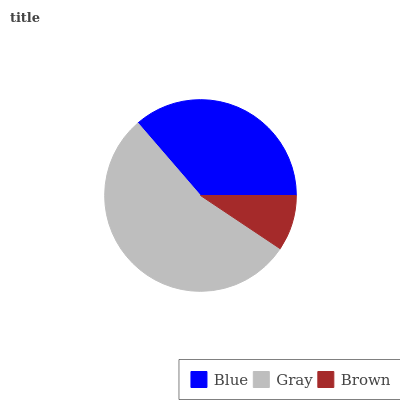Is Brown the minimum?
Answer yes or no. Yes. Is Gray the maximum?
Answer yes or no. Yes. Is Gray the minimum?
Answer yes or no. No. Is Brown the maximum?
Answer yes or no. No. Is Gray greater than Brown?
Answer yes or no. Yes. Is Brown less than Gray?
Answer yes or no. Yes. Is Brown greater than Gray?
Answer yes or no. No. Is Gray less than Brown?
Answer yes or no. No. Is Blue the high median?
Answer yes or no. Yes. Is Blue the low median?
Answer yes or no. Yes. Is Brown the high median?
Answer yes or no. No. Is Brown the low median?
Answer yes or no. No. 